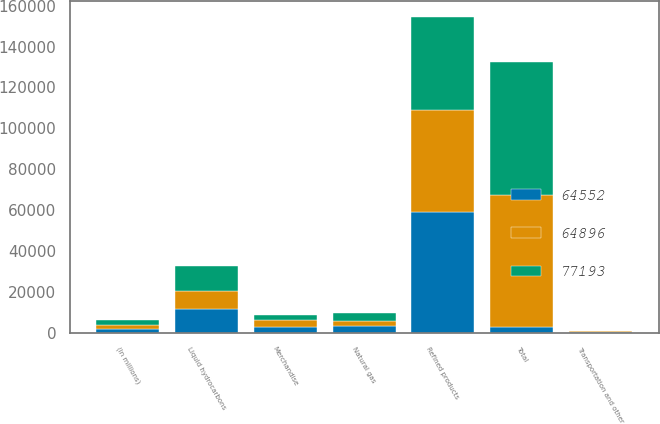<chart> <loc_0><loc_0><loc_500><loc_500><stacked_bar_chart><ecel><fcel>(In millions)<fcel>Refined products<fcel>Merchandise<fcel>Liquid hydrocarbons<fcel>Natural gas<fcel>Transportation and other<fcel>Total<nl><fcel>64552<fcel>2008<fcel>59299<fcel>3028<fcel>11422<fcel>3085<fcel>359<fcel>3056.5<nl><fcel>64896<fcel>2007<fcel>49718<fcel>2975<fcel>8919<fcel>2629<fcel>311<fcel>64552<nl><fcel>77193<fcel>2006<fcel>45511<fcel>2871<fcel>12531<fcel>3742<fcel>241<fcel>64896<nl></chart> 